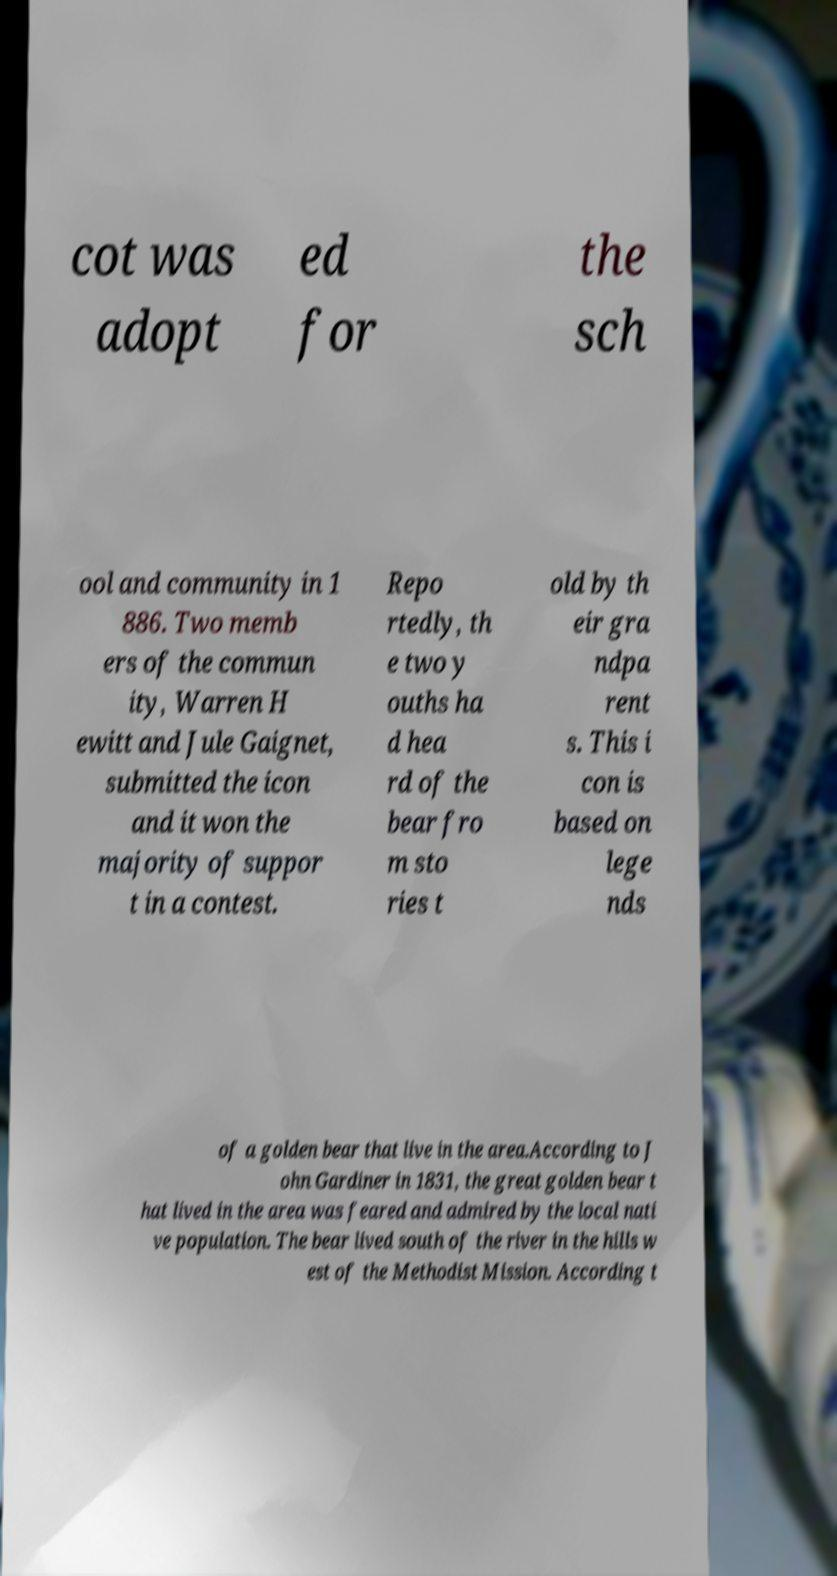There's text embedded in this image that I need extracted. Can you transcribe it verbatim? cot was adopt ed for the sch ool and community in 1 886. Two memb ers of the commun ity, Warren H ewitt and Jule Gaignet, submitted the icon and it won the majority of suppor t in a contest. Repo rtedly, th e two y ouths ha d hea rd of the bear fro m sto ries t old by th eir gra ndpa rent s. This i con is based on lege nds of a golden bear that live in the area.According to J ohn Gardiner in 1831, the great golden bear t hat lived in the area was feared and admired by the local nati ve population. The bear lived south of the river in the hills w est of the Methodist Mission. According t 